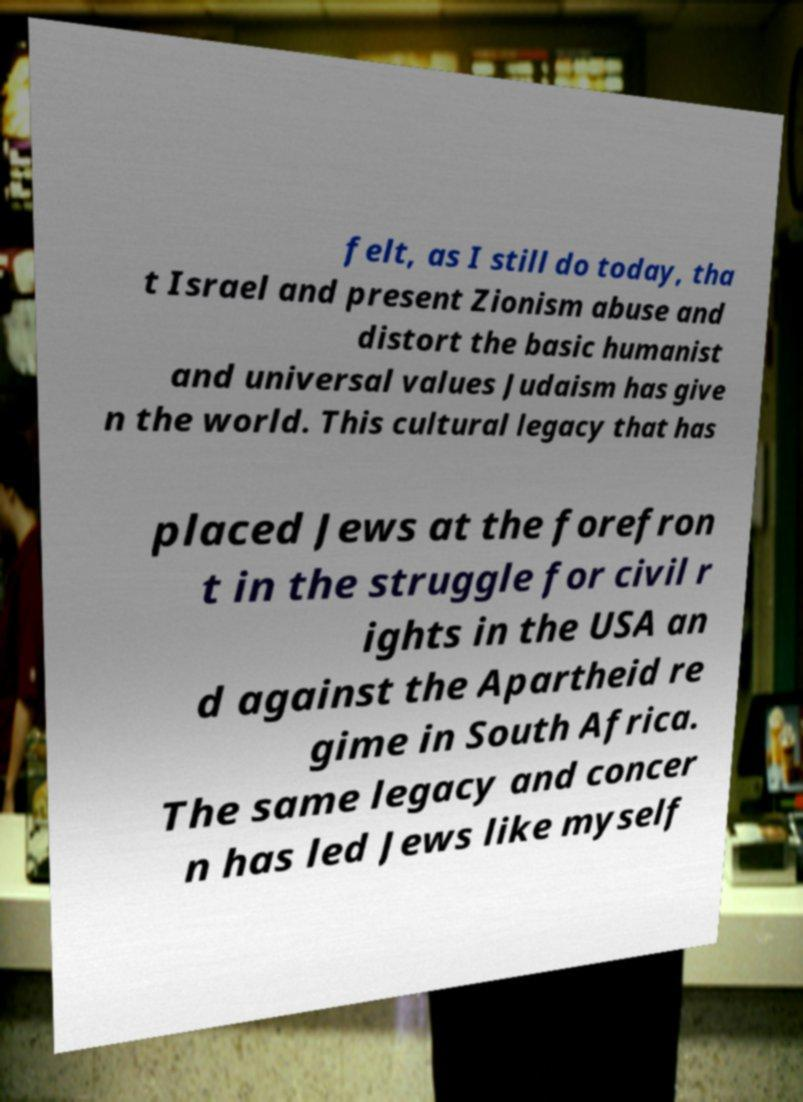Please read and relay the text visible in this image. What does it say? felt, as I still do today, tha t Israel and present Zionism abuse and distort the basic humanist and universal values Judaism has give n the world. This cultural legacy that has placed Jews at the forefron t in the struggle for civil r ights in the USA an d against the Apartheid re gime in South Africa. The same legacy and concer n has led Jews like myself 